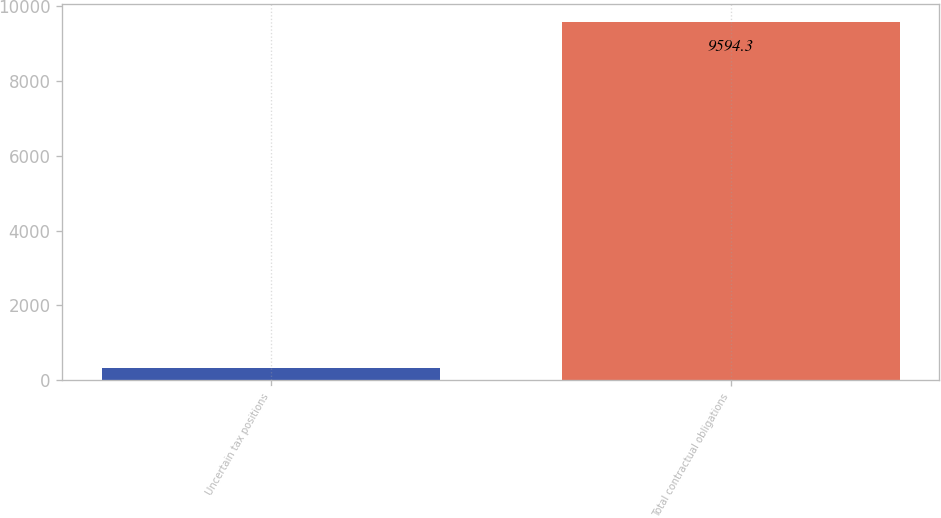Convert chart. <chart><loc_0><loc_0><loc_500><loc_500><bar_chart><fcel>Uncertain tax positions<fcel>Total contractual obligations<nl><fcel>332.9<fcel>9594.3<nl></chart> 